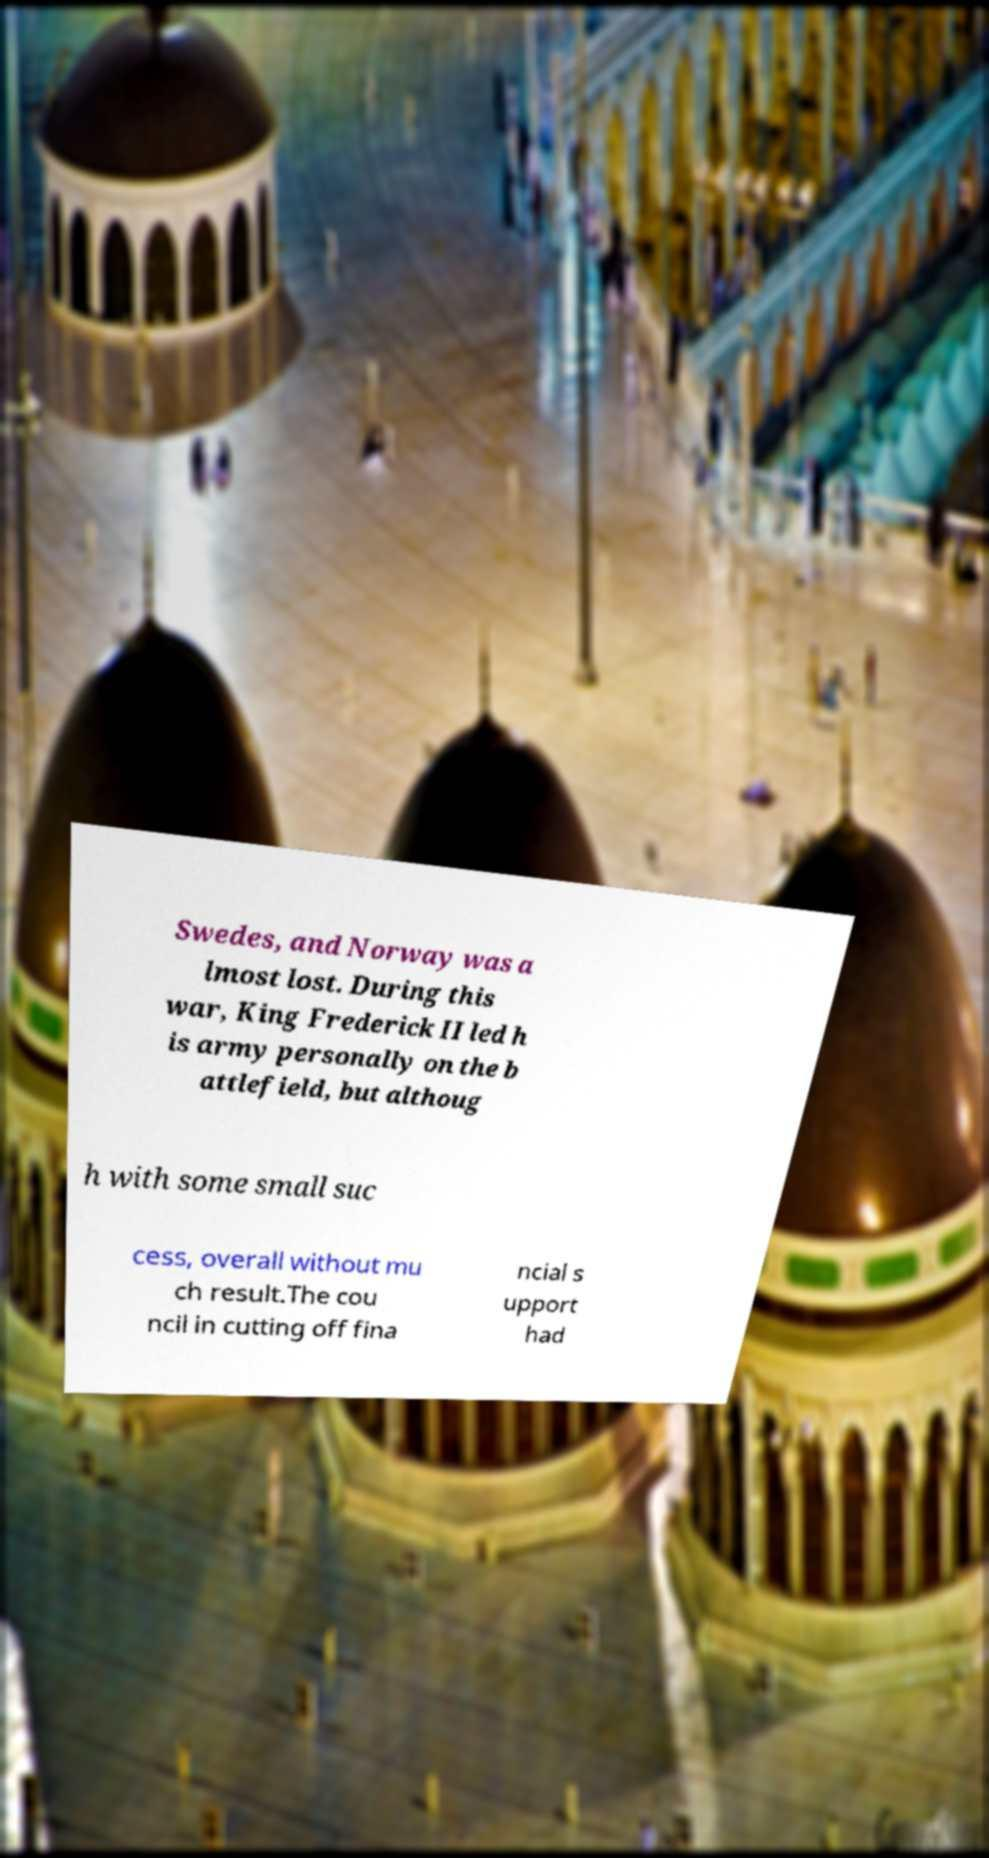Please read and relay the text visible in this image. What does it say? Swedes, and Norway was a lmost lost. During this war, King Frederick II led h is army personally on the b attlefield, but althoug h with some small suc cess, overall without mu ch result.The cou ncil in cutting off fina ncial s upport had 